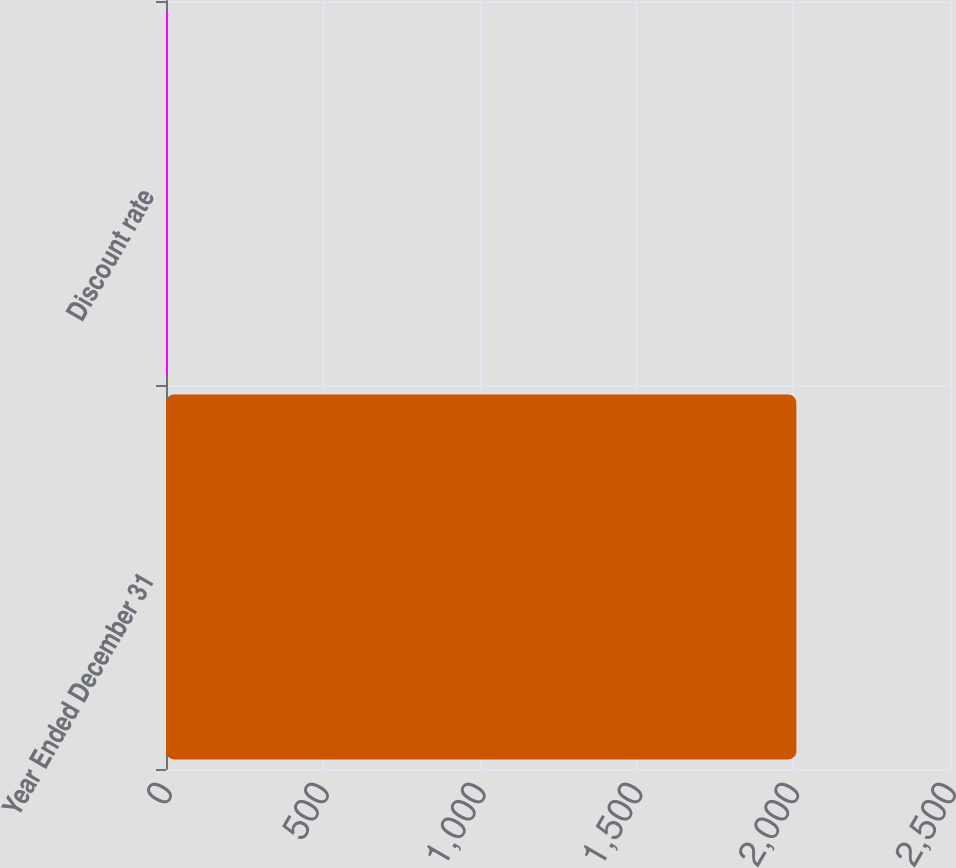<chart> <loc_0><loc_0><loc_500><loc_500><bar_chart><fcel>Year Ended December 31<fcel>Discount rate<nl><fcel>2010<fcel>5.6<nl></chart> 